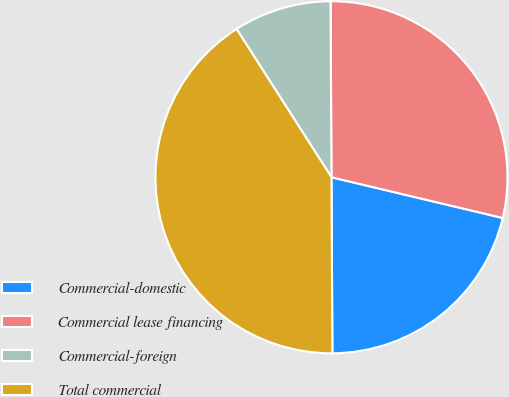<chart> <loc_0><loc_0><loc_500><loc_500><pie_chart><fcel>Commercial-domestic<fcel>Commercial lease financing<fcel>Commercial-foreign<fcel>Total commercial<nl><fcel>21.2%<fcel>28.8%<fcel>8.98%<fcel>41.02%<nl></chart> 